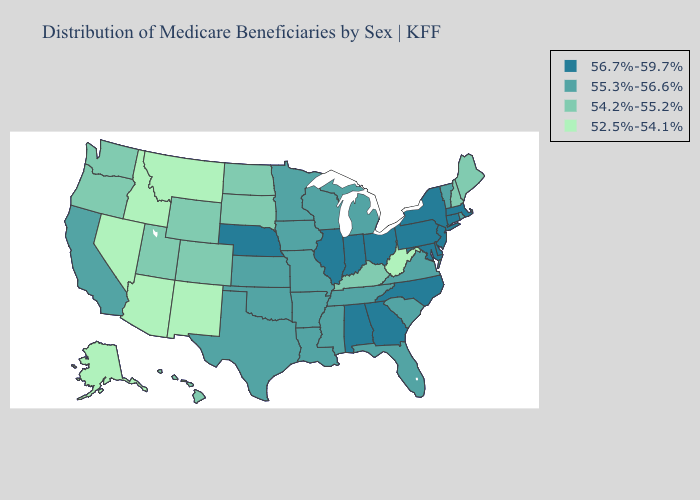How many symbols are there in the legend?
Write a very short answer. 4. What is the highest value in states that border New York?
Give a very brief answer. 56.7%-59.7%. What is the highest value in the Northeast ?
Be succinct. 56.7%-59.7%. What is the value of Nebraska?
Keep it brief. 56.7%-59.7%. What is the lowest value in the Northeast?
Write a very short answer. 54.2%-55.2%. Among the states that border North Carolina , which have the lowest value?
Be succinct. South Carolina, Tennessee, Virginia. Which states have the lowest value in the Northeast?
Quick response, please. Maine, New Hampshire. Is the legend a continuous bar?
Answer briefly. No. Name the states that have a value in the range 52.5%-54.1%?
Answer briefly. Alaska, Arizona, Idaho, Montana, Nevada, New Mexico, West Virginia. Does Iowa have the lowest value in the MidWest?
Be succinct. No. What is the highest value in the MidWest ?
Keep it brief. 56.7%-59.7%. Among the states that border Texas , which have the lowest value?
Give a very brief answer. New Mexico. Does Louisiana have a lower value than Georgia?
Be succinct. Yes. Name the states that have a value in the range 54.2%-55.2%?
Quick response, please. Colorado, Hawaii, Kentucky, Maine, New Hampshire, North Dakota, Oregon, South Dakota, Utah, Washington, Wyoming. Among the states that border Arkansas , which have the lowest value?
Concise answer only. Louisiana, Mississippi, Missouri, Oklahoma, Tennessee, Texas. 